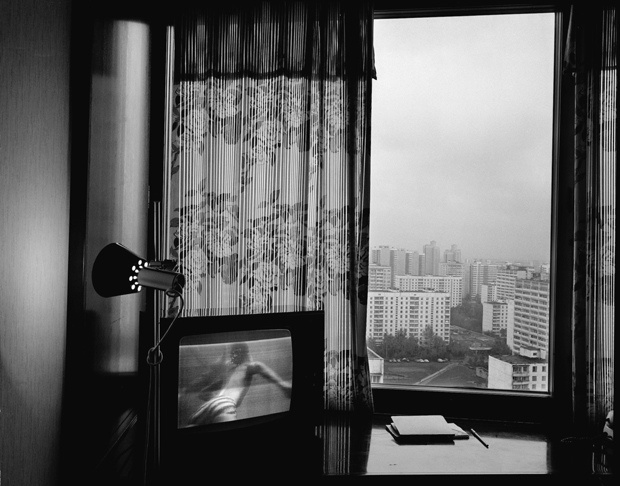Describe the objects in this image and their specific colors. I can see a tv in black, gray, darkgray, and lightgray tones in this image. 